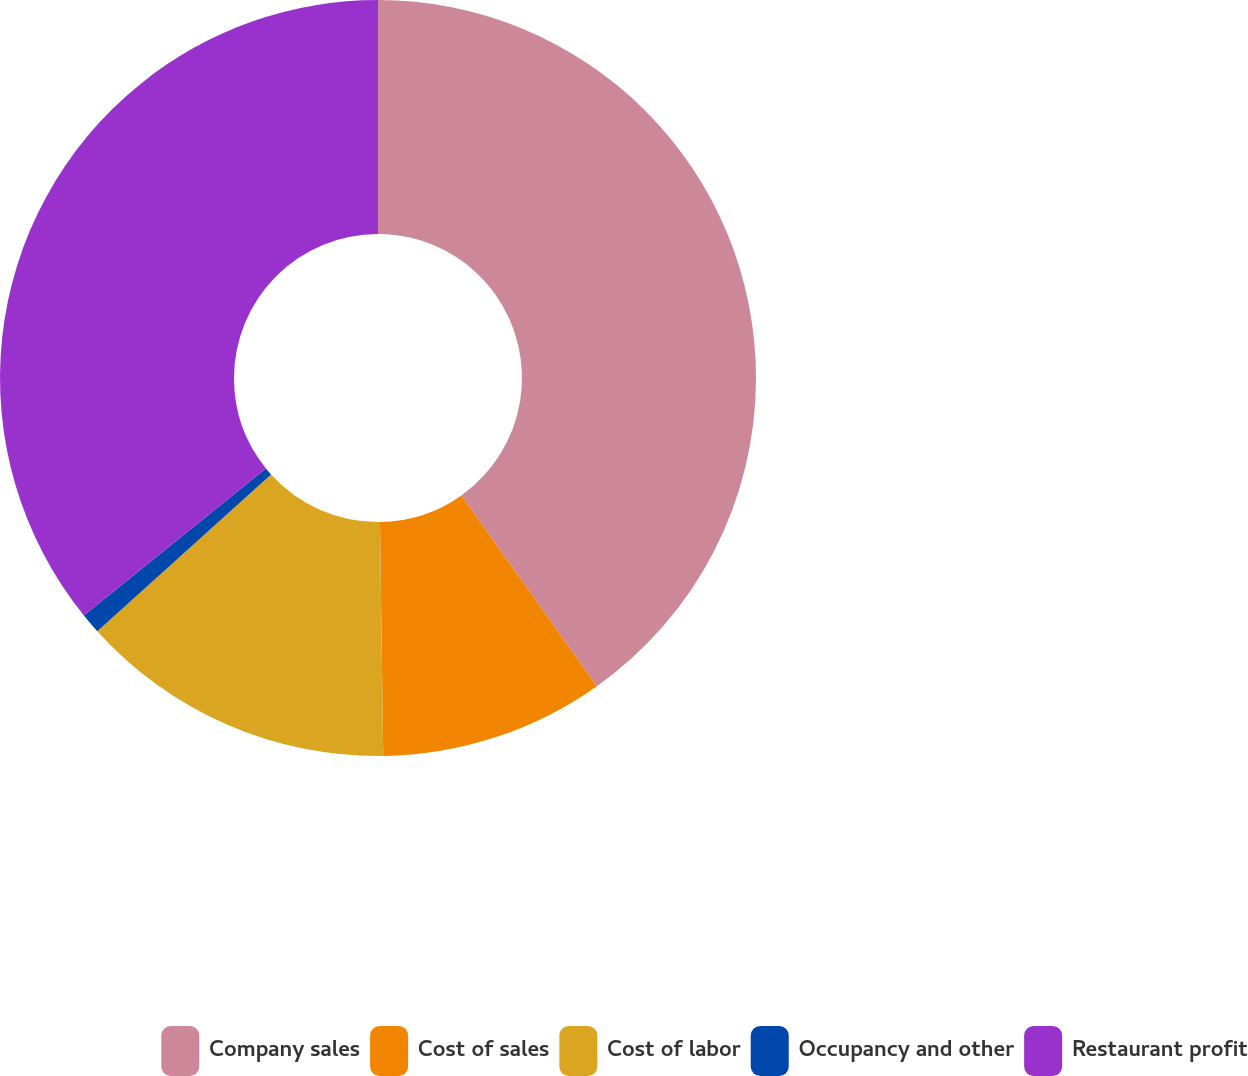Convert chart. <chart><loc_0><loc_0><loc_500><loc_500><pie_chart><fcel>Company sales<fcel>Cost of sales<fcel>Cost of labor<fcel>Occupancy and other<fcel>Restaurant profit<nl><fcel>40.17%<fcel>9.61%<fcel>13.54%<fcel>0.87%<fcel>35.81%<nl></chart> 